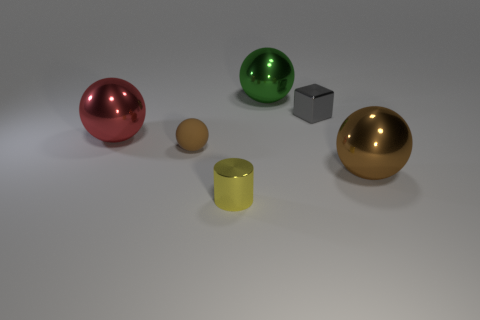There is another large thing that is the same color as the rubber thing; what material is it?
Your response must be concise. Metal. Are there more small brown objects than brown objects?
Your response must be concise. No. Is the material of the gray thing the same as the small sphere?
Your answer should be compact. No. Are there the same number of big things that are on the right side of the small yellow shiny thing and big cyan rubber things?
Keep it short and to the point. No. What number of large red things are made of the same material as the yellow cylinder?
Ensure brevity in your answer.  1. Is the number of tiny yellow cylinders less than the number of tiny purple matte cubes?
Keep it short and to the point. No. There is a big object that is in front of the large red metal thing; is its color the same as the small matte ball?
Your answer should be compact. Yes. There is a tiny brown rubber sphere on the left side of the big ball behind the metallic block; how many blocks are right of it?
Offer a terse response. 1. How many large shiny balls are in front of the gray block?
Give a very brief answer. 2. The other matte thing that is the same shape as the big green thing is what color?
Your response must be concise. Brown. 